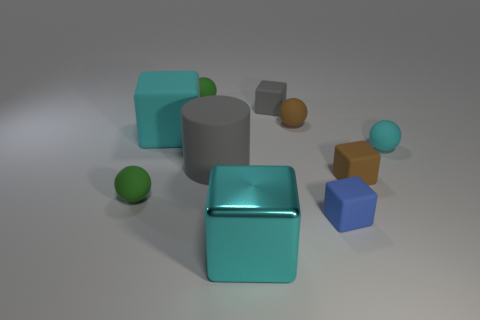Do the shiny thing and the big rubber cylinder that is in front of the small cyan matte thing have the same color?
Your answer should be compact. No. There is a tiny blue object that is the same material as the tiny gray object; what is its shape?
Your answer should be compact. Cube. What number of matte spheres are there?
Offer a terse response. 4. What number of objects are tiny balls that are behind the big rubber cylinder or big things?
Your answer should be compact. 6. Does the matte thing on the left side of the big rubber cube have the same color as the metallic thing?
Provide a short and direct response. No. What number of other objects are the same color as the big rubber cylinder?
Your response must be concise. 1. What number of small things are spheres or blue things?
Make the answer very short. 5. Are there more big gray things than tiny brown shiny spheres?
Your answer should be compact. Yes. Does the large cylinder have the same material as the brown block?
Give a very brief answer. Yes. Is there any other thing that is the same material as the gray cylinder?
Provide a succinct answer. Yes. 